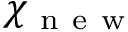<formula> <loc_0><loc_0><loc_500><loc_500>\mathbb { \chi } _ { n e w }</formula> 